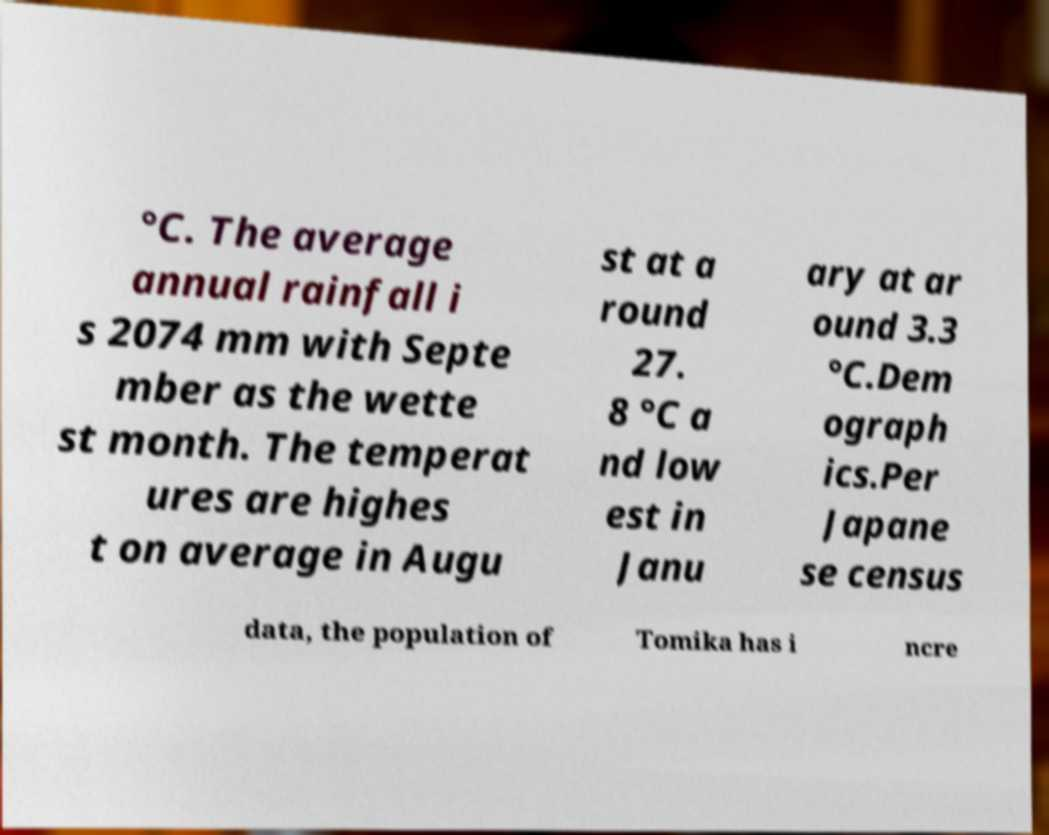For documentation purposes, I need the text within this image transcribed. Could you provide that? °C. The average annual rainfall i s 2074 mm with Septe mber as the wette st month. The temperat ures are highes t on average in Augu st at a round 27. 8 °C a nd low est in Janu ary at ar ound 3.3 °C.Dem ograph ics.Per Japane se census data, the population of Tomika has i ncre 